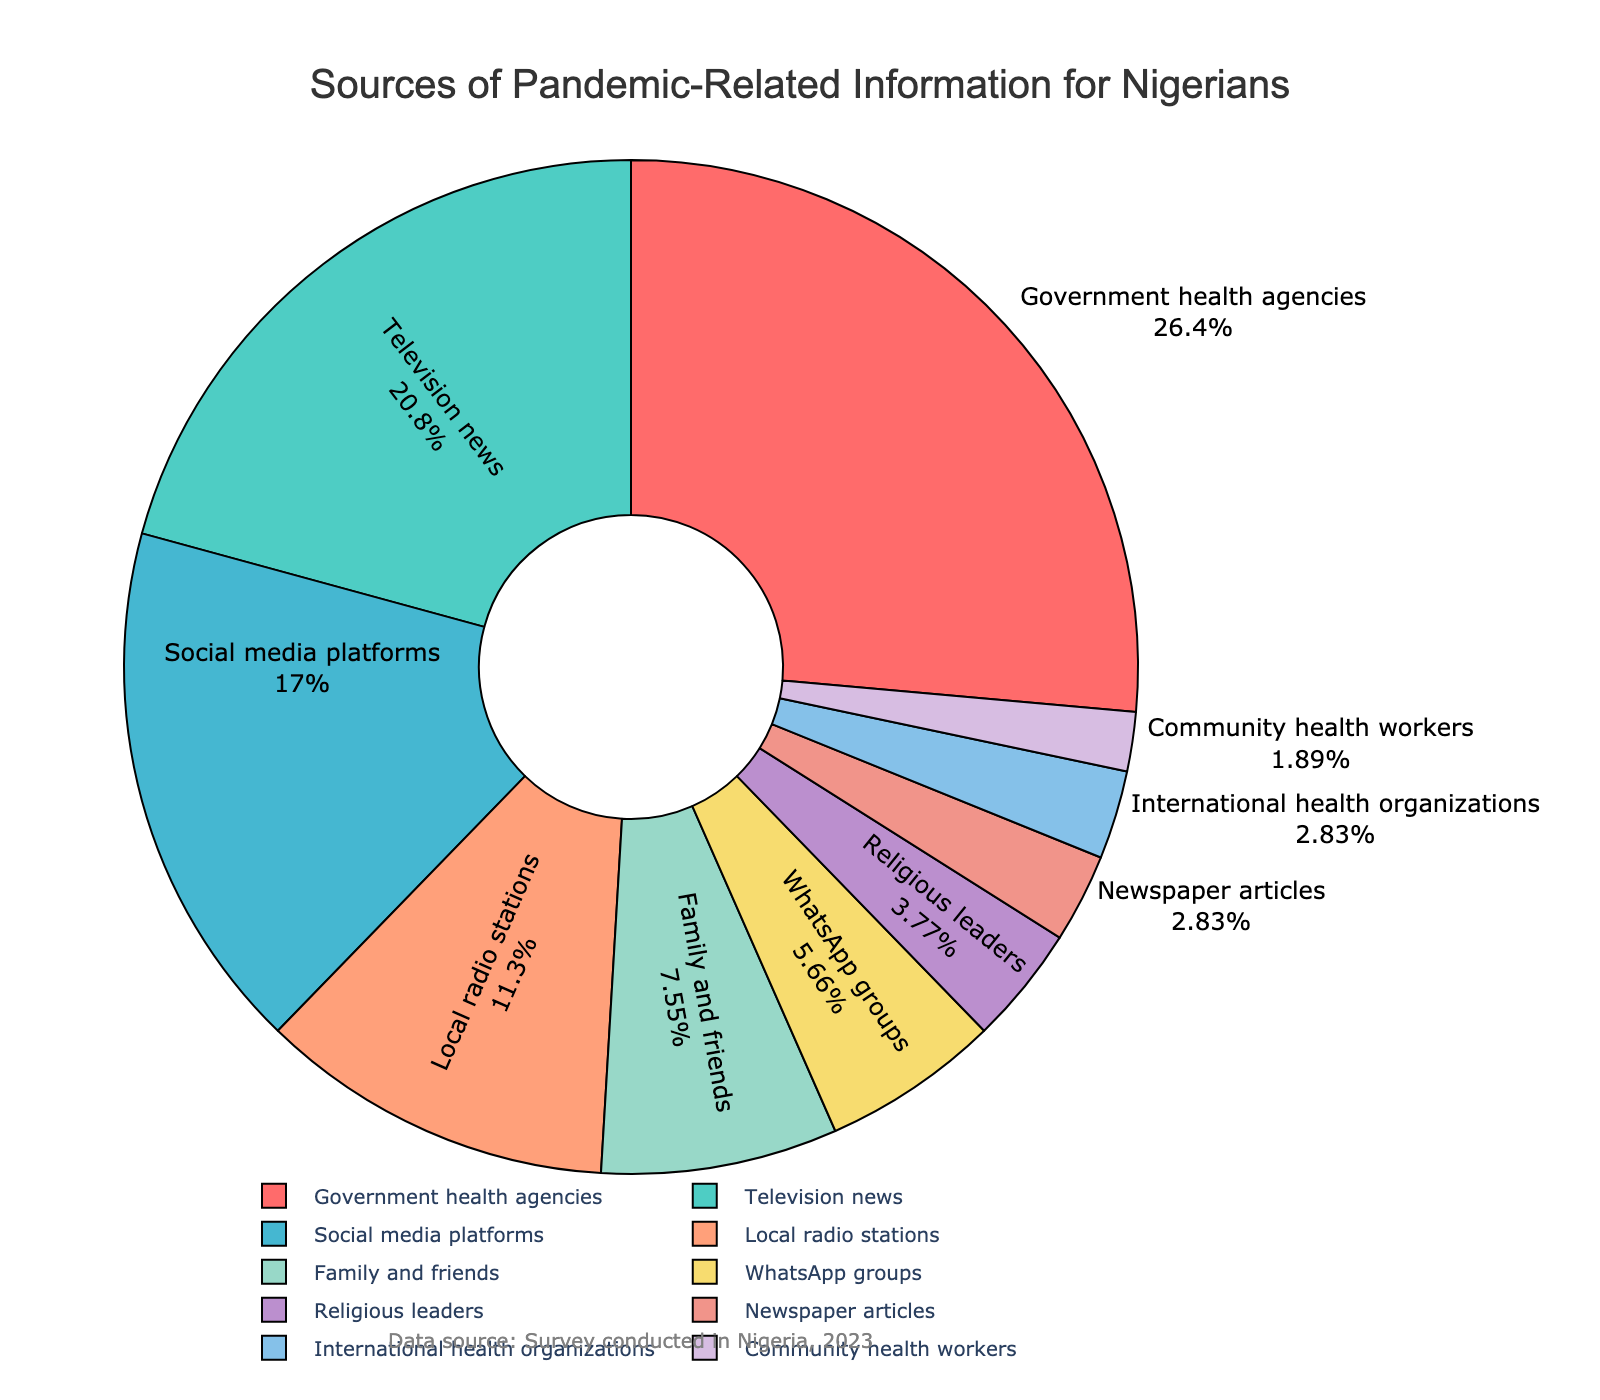what is the largest source of pandemic-related information for Nigerians? The largest source has the biggest percentage on the pie chart. From the chart, it is "Government health agencies" with 28%.
Answer: Government health agencies What sources combined constitute more than 50% of the information? We add percentages from the largest downward until we exceed 50%. Adding the top two percentages (28% + 22% = 50%) exactly equals 50%. To exceed 50%, we must also add the next source, "Social media platforms" (18%). Thus, the sources are "Government health agencies," "Television news," and "Social media platforms."
Answer: Government health agencies, Television news, and Social media platforms By how much is the percentage of information from local radio stations greater than from WhatsApp groups? Subtract the percentage of WhatsApp groups (6%) from that of local radio stations (12%). 12% - 6% = 6%.
Answer: 6% What percentage of information comes from sources that are neither governmental agencies nor mass media (TV and radio)? We exclude "Government health agencies" (28%) and "Television news" (22%) and "Local radio stations" (12%). Thus, the remaining sources (18% + 8% + 6% + 4% + 3% + 3% + 2%) give us the percentage. Adding 18% + 8% + 6% + 4% + 3% + 3% + 2% = 44%.
Answer: 44% Which is more common, information from family and friends or from religious leaders, and by how much? Compare the percentages of "Family and friends" (8%) and "Religious leaders" (4%). The percentage for family and friends is higher by 8% - 4% = 4%.
Answer: Family and friends, 4% Are the sources "Newspaper articles" and "International health organizations" equally common? We look at the chart and see that both "Newspaper articles" and "International health organizations" are each at 3%.
Answer: Yes Identify the source of information represented by the green color in the pie chart. Since it's not visible from the dataset and code, we identify it based on the ordered color list and the dataset. The fourth entry ("Local radio stations") is likely green.
Answer: Local radio stations Which type of source of information is the least common, and what is its percentage? To find the least common source, look for the smallest percentage in the chart. "Community health workers" have the smallest percentage at 2%.
Answer: Community health workers What is the combined percentage of information from "WhatsApp groups" and "Religious leaders"? Add the percentages for "WhatsApp groups" (6%) and "Religious leaders" (4%). 6% + 4% = 10%.
Answer: 10% Is the percentage of information from social media platforms higher than that from family and friends and WhatsApp groups combined? Compare "Social media platforms" (18%) with the sum of "Family and friends" (8%) and "WhatsApp groups" (6%). 8% + 6% = 14%. Since 18% is greater than 14%, the answer is yes.
Answer: Yes 